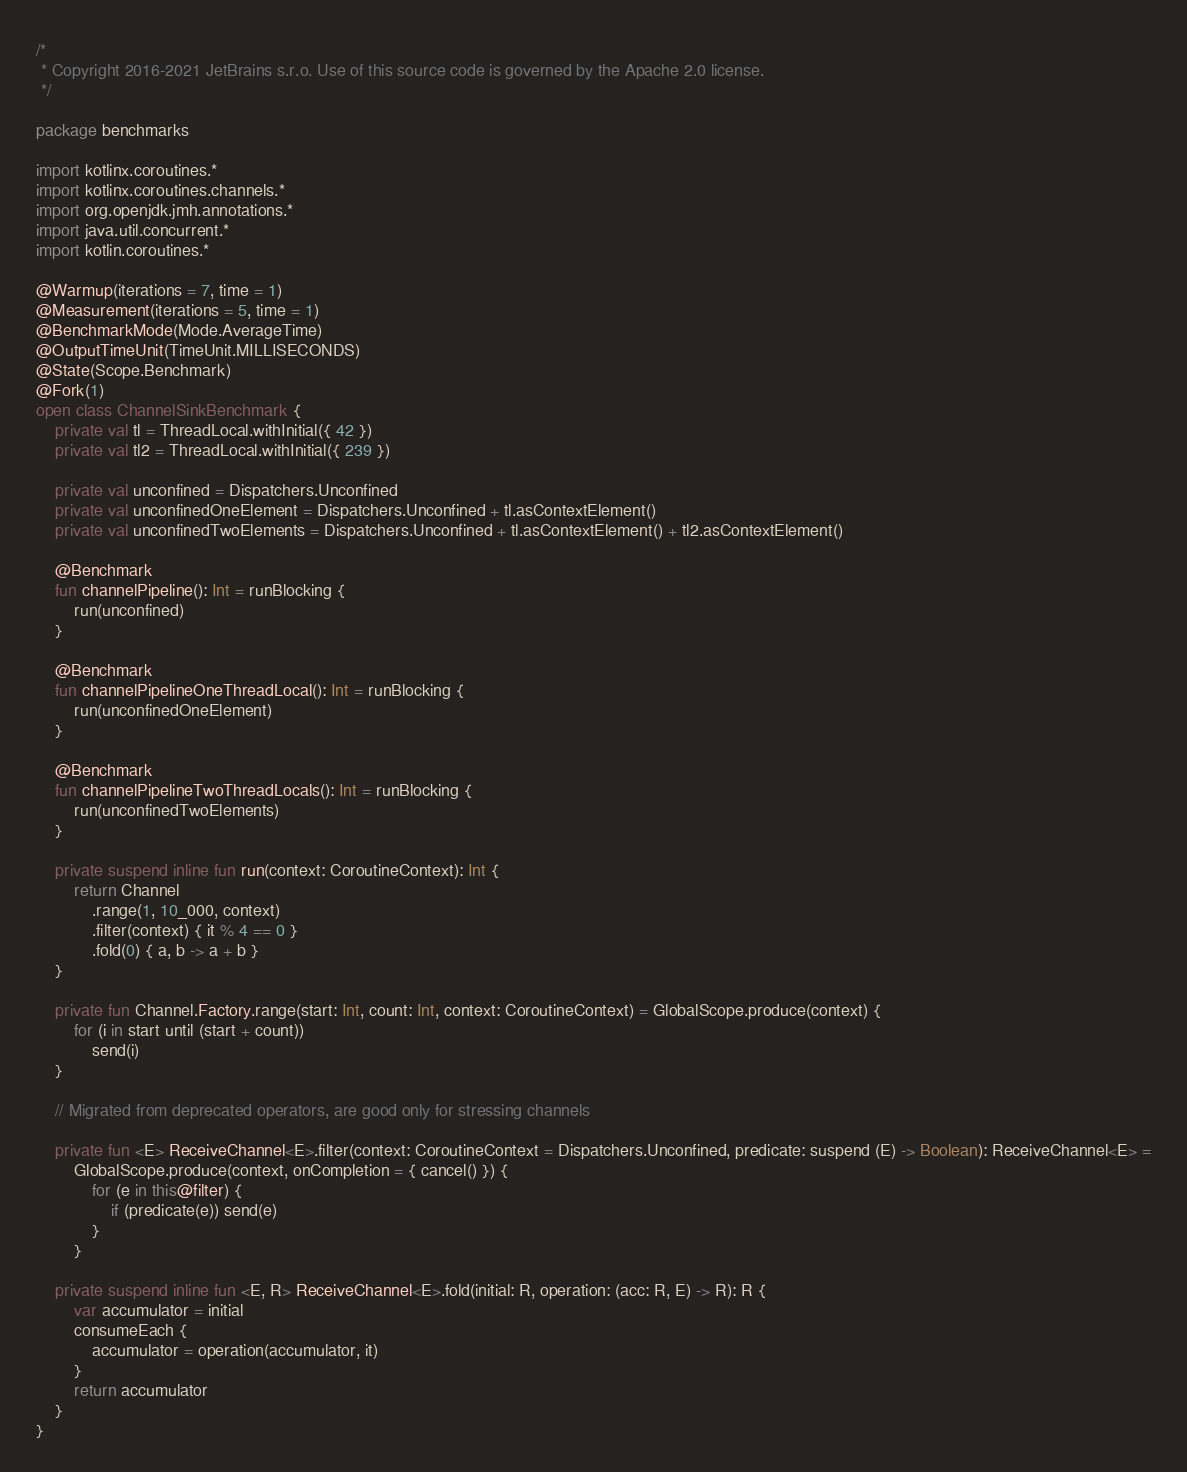Convert code to text. <code><loc_0><loc_0><loc_500><loc_500><_Kotlin_>/*
 * Copyright 2016-2021 JetBrains s.r.o. Use of this source code is governed by the Apache 2.0 license.
 */

package benchmarks

import kotlinx.coroutines.*
import kotlinx.coroutines.channels.*
import org.openjdk.jmh.annotations.*
import java.util.concurrent.*
import kotlin.coroutines.*

@Warmup(iterations = 7, time = 1)
@Measurement(iterations = 5, time = 1)
@BenchmarkMode(Mode.AverageTime)
@OutputTimeUnit(TimeUnit.MILLISECONDS)
@State(Scope.Benchmark)
@Fork(1)
open class ChannelSinkBenchmark {
    private val tl = ThreadLocal.withInitial({ 42 })
    private val tl2 = ThreadLocal.withInitial({ 239 })

    private val unconfined = Dispatchers.Unconfined
    private val unconfinedOneElement = Dispatchers.Unconfined + tl.asContextElement()
    private val unconfinedTwoElements = Dispatchers.Unconfined + tl.asContextElement() + tl2.asContextElement()

    @Benchmark
    fun channelPipeline(): Int = runBlocking {
        run(unconfined)
    }

    @Benchmark
    fun channelPipelineOneThreadLocal(): Int = runBlocking {
        run(unconfinedOneElement)
    }

    @Benchmark
    fun channelPipelineTwoThreadLocals(): Int = runBlocking {
        run(unconfinedTwoElements)
    }

    private suspend inline fun run(context: CoroutineContext): Int {
        return Channel
            .range(1, 10_000, context)
            .filter(context) { it % 4 == 0 }
            .fold(0) { a, b -> a + b }
    }

    private fun Channel.Factory.range(start: Int, count: Int, context: CoroutineContext) = GlobalScope.produce(context) {
        for (i in start until (start + count))
            send(i)
    }

    // Migrated from deprecated operators, are good only for stressing channels

    private fun <E> ReceiveChannel<E>.filter(context: CoroutineContext = Dispatchers.Unconfined, predicate: suspend (E) -> Boolean): ReceiveChannel<E> =
        GlobalScope.produce(context, onCompletion = { cancel() }) {
            for (e in this@filter) {
                if (predicate(e)) send(e)
            }
        }

    private suspend inline fun <E, R> ReceiveChannel<E>.fold(initial: R, operation: (acc: R, E) -> R): R {
        var accumulator = initial
        consumeEach {
            accumulator = operation(accumulator, it)
        }
        return accumulator
    }
}

</code> 